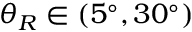Convert formula to latex. <formula><loc_0><loc_0><loc_500><loc_500>{ \theta _ { R } } \in ( 5 ^ { \circ } , 3 0 ^ { \circ } )</formula> 